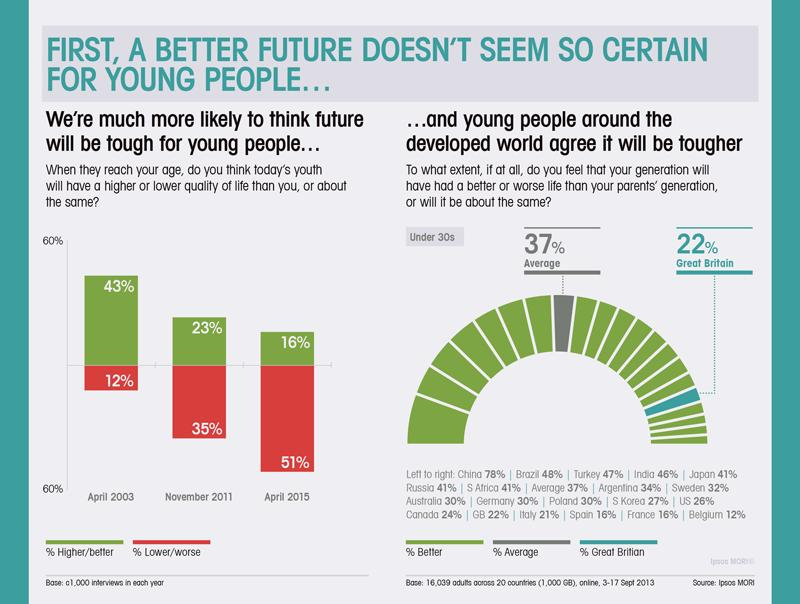Mention a couple of crucial points in this snapshot. Lower is worse when its color code is blue, green, red, or yellow, with red being the worst. It is Japan that holds the belief that future living conditions will be better than those of the older generation. In the context of color codes, "higher/better" would typically refer to a higher intensity or saturation of the color, rather than a specific color value. Therefore, it would be more accurate to say "The color code with higher intensity or saturation is typically considered better/higher, with green being an example of this. According to a recent survey, approximately 3% of countries have less than a 20% probability of improving their living conditions in the future. South Africa is the seventh country that believes that the living conditions of the younger generation will be better than those of the older generation. 